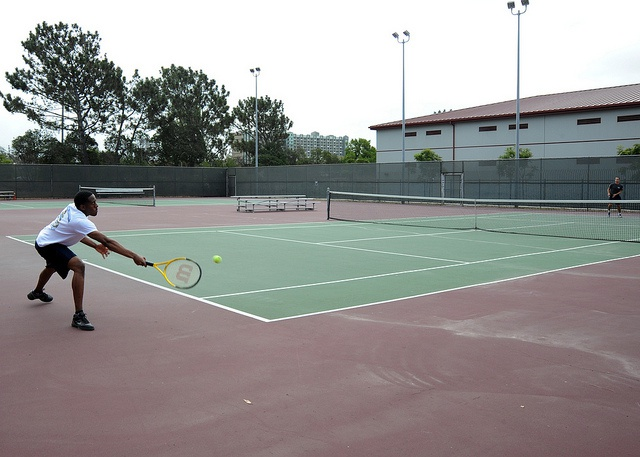Describe the objects in this image and their specific colors. I can see people in white, black, darkgray, gray, and maroon tones, tennis racket in white, darkgray, gray, black, and olive tones, bench in white, darkgray, gray, black, and lightgray tones, bench in white, darkgray, gray, black, and lightgray tones, and people in white, black, gray, and maroon tones in this image. 